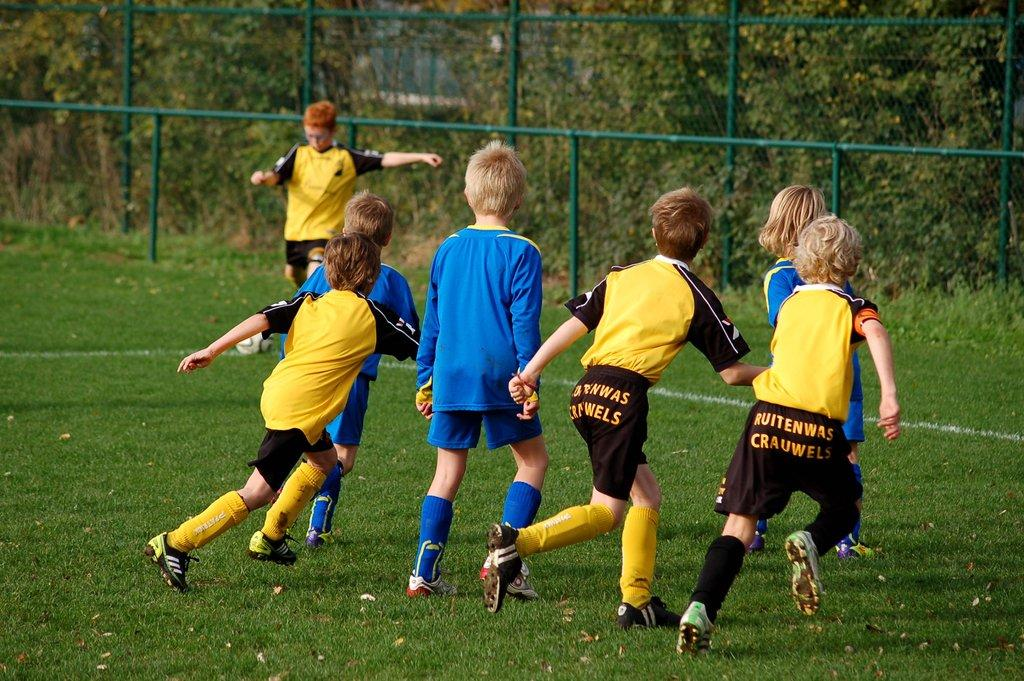<image>
Write a terse but informative summary of the picture. kids on yellow and blue soccer teams with ruitenwas crauwels written on the black team shorts 